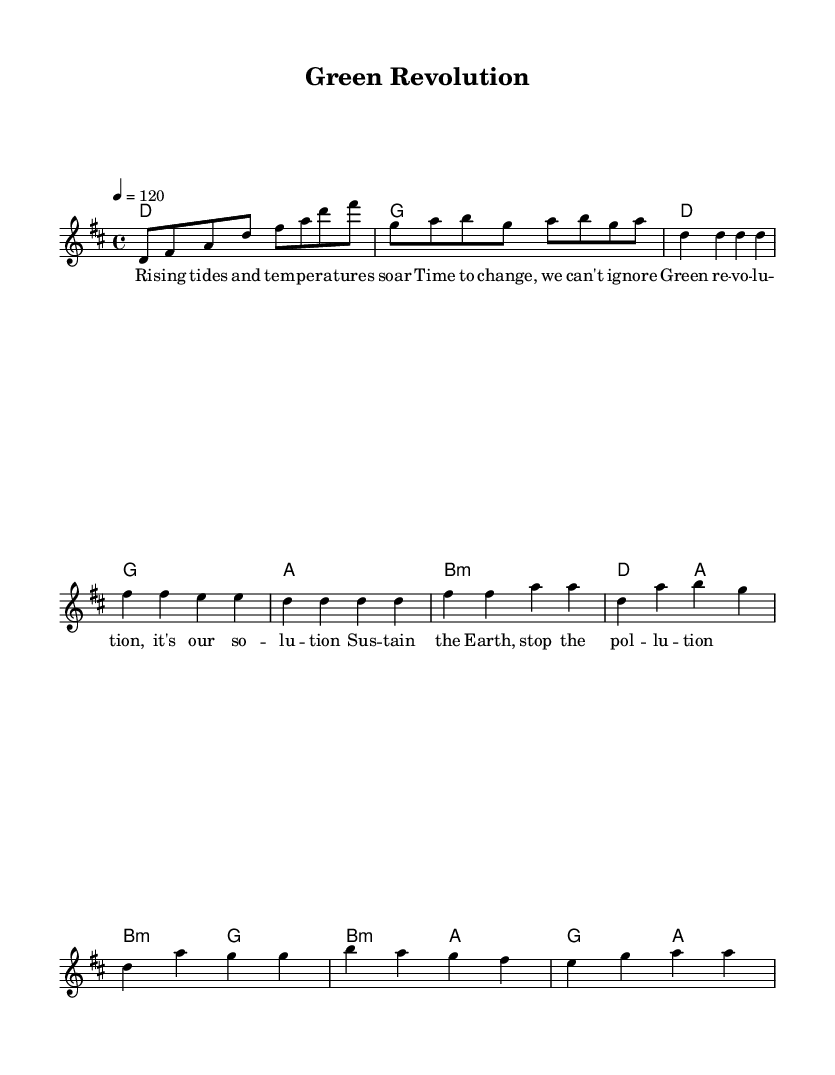What is the key signature of this music? The key signature is D major, which has two sharps (F# and C#). This can be identified at the beginning of the staff, where the sharps are notated.
Answer: D major What is the time signature of the piece? The time signature is 4/4, indicated at the beginning of the score, which means there are four beats per measure and a quarter note receives one beat.
Answer: 4/4 What is the tempo marking for this piece? The tempo marking is 120 beats per minute, which is specified in the tempo instruction. This indicates the speed at which the piece should be played.
Answer: 120 How many measures are in the chorus section? The chorus consists of 4 measures, which can be counted from the musical notation provided in the chorus section of the score.
Answer: 4 What type of chords are used in the verse? The verse features D, G, A, and B minor chords, which can be identified in the chord symbols written above the staff corresponding to the verse section.
Answer: D, G, A, B minor How many unique musical sections does this piece have? The piece contains four unique sections: Intro, Verse, Chorus, and Bridge. Each section is distinct in terms of melody and harmony, identifiable by their labels and structure.
Answer: 4 What is the main theme of the lyrics provided? The main theme of the lyrics addresses climate change and sustainability, as indicated by phrases like "Green revolution" and "sustain the Earth". This thematic focus can be inferred from the lyric content related to activism.
Answer: Climate change and sustainability 